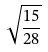Convert formula to latex. <formula><loc_0><loc_0><loc_500><loc_500>\sqrt { \frac { 1 5 } { 2 8 } }</formula> 